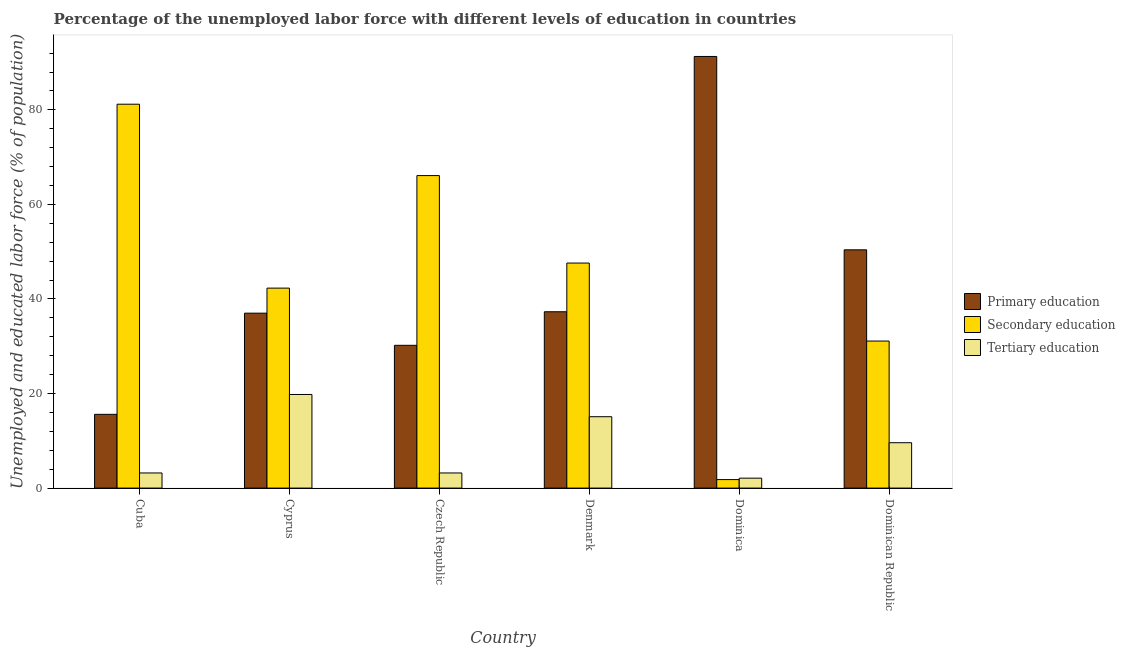Are the number of bars per tick equal to the number of legend labels?
Offer a terse response. Yes. How many bars are there on the 2nd tick from the right?
Offer a terse response. 3. What is the label of the 1st group of bars from the left?
Provide a succinct answer. Cuba. In how many cases, is the number of bars for a given country not equal to the number of legend labels?
Make the answer very short. 0. What is the percentage of labor force who received secondary education in Czech Republic?
Ensure brevity in your answer.  66.1. Across all countries, what is the maximum percentage of labor force who received primary education?
Provide a short and direct response. 91.3. Across all countries, what is the minimum percentage of labor force who received tertiary education?
Give a very brief answer. 2.1. In which country was the percentage of labor force who received secondary education maximum?
Keep it short and to the point. Cuba. In which country was the percentage of labor force who received primary education minimum?
Offer a terse response. Cuba. What is the total percentage of labor force who received secondary education in the graph?
Give a very brief answer. 270.1. What is the difference between the percentage of labor force who received primary education in Denmark and that in Dominica?
Make the answer very short. -54. What is the difference between the percentage of labor force who received tertiary education in Cyprus and the percentage of labor force who received secondary education in Czech Republic?
Give a very brief answer. -46.3. What is the average percentage of labor force who received primary education per country?
Your answer should be compact. 43.63. What is the difference between the percentage of labor force who received primary education and percentage of labor force who received tertiary education in Czech Republic?
Give a very brief answer. 27. What is the ratio of the percentage of labor force who received tertiary education in Cyprus to that in Dominican Republic?
Ensure brevity in your answer.  2.06. What is the difference between the highest and the second highest percentage of labor force who received secondary education?
Make the answer very short. 15.1. What is the difference between the highest and the lowest percentage of labor force who received primary education?
Keep it short and to the point. 75.7. In how many countries, is the percentage of labor force who received secondary education greater than the average percentage of labor force who received secondary education taken over all countries?
Ensure brevity in your answer.  3. What does the 2nd bar from the left in Cuba represents?
Keep it short and to the point. Secondary education. What is the difference between two consecutive major ticks on the Y-axis?
Give a very brief answer. 20. Does the graph contain any zero values?
Give a very brief answer. No. Does the graph contain grids?
Your answer should be very brief. No. Where does the legend appear in the graph?
Your answer should be compact. Center right. How many legend labels are there?
Provide a succinct answer. 3. What is the title of the graph?
Provide a short and direct response. Percentage of the unemployed labor force with different levels of education in countries. What is the label or title of the Y-axis?
Ensure brevity in your answer.  Unemployed and educated labor force (% of population). What is the Unemployed and educated labor force (% of population) of Primary education in Cuba?
Provide a short and direct response. 15.6. What is the Unemployed and educated labor force (% of population) in Secondary education in Cuba?
Provide a short and direct response. 81.2. What is the Unemployed and educated labor force (% of population) of Tertiary education in Cuba?
Make the answer very short. 3.2. What is the Unemployed and educated labor force (% of population) in Primary education in Cyprus?
Keep it short and to the point. 37. What is the Unemployed and educated labor force (% of population) in Secondary education in Cyprus?
Offer a very short reply. 42.3. What is the Unemployed and educated labor force (% of population) in Tertiary education in Cyprus?
Provide a short and direct response. 19.8. What is the Unemployed and educated labor force (% of population) of Primary education in Czech Republic?
Ensure brevity in your answer.  30.2. What is the Unemployed and educated labor force (% of population) of Secondary education in Czech Republic?
Your answer should be compact. 66.1. What is the Unemployed and educated labor force (% of population) in Tertiary education in Czech Republic?
Your answer should be compact. 3.2. What is the Unemployed and educated labor force (% of population) in Primary education in Denmark?
Give a very brief answer. 37.3. What is the Unemployed and educated labor force (% of population) in Secondary education in Denmark?
Provide a short and direct response. 47.6. What is the Unemployed and educated labor force (% of population) in Tertiary education in Denmark?
Offer a terse response. 15.1. What is the Unemployed and educated labor force (% of population) in Primary education in Dominica?
Offer a very short reply. 91.3. What is the Unemployed and educated labor force (% of population) of Secondary education in Dominica?
Your answer should be compact. 1.8. What is the Unemployed and educated labor force (% of population) in Tertiary education in Dominica?
Your response must be concise. 2.1. What is the Unemployed and educated labor force (% of population) of Primary education in Dominican Republic?
Give a very brief answer. 50.4. What is the Unemployed and educated labor force (% of population) in Secondary education in Dominican Republic?
Provide a short and direct response. 31.1. What is the Unemployed and educated labor force (% of population) of Tertiary education in Dominican Republic?
Offer a terse response. 9.6. Across all countries, what is the maximum Unemployed and educated labor force (% of population) of Primary education?
Ensure brevity in your answer.  91.3. Across all countries, what is the maximum Unemployed and educated labor force (% of population) of Secondary education?
Offer a terse response. 81.2. Across all countries, what is the maximum Unemployed and educated labor force (% of population) of Tertiary education?
Ensure brevity in your answer.  19.8. Across all countries, what is the minimum Unemployed and educated labor force (% of population) in Primary education?
Your response must be concise. 15.6. Across all countries, what is the minimum Unemployed and educated labor force (% of population) of Secondary education?
Your answer should be compact. 1.8. Across all countries, what is the minimum Unemployed and educated labor force (% of population) in Tertiary education?
Provide a short and direct response. 2.1. What is the total Unemployed and educated labor force (% of population) of Primary education in the graph?
Ensure brevity in your answer.  261.8. What is the total Unemployed and educated labor force (% of population) in Secondary education in the graph?
Your response must be concise. 270.1. What is the total Unemployed and educated labor force (% of population) of Tertiary education in the graph?
Ensure brevity in your answer.  53. What is the difference between the Unemployed and educated labor force (% of population) in Primary education in Cuba and that in Cyprus?
Make the answer very short. -21.4. What is the difference between the Unemployed and educated labor force (% of population) in Secondary education in Cuba and that in Cyprus?
Offer a terse response. 38.9. What is the difference between the Unemployed and educated labor force (% of population) in Tertiary education in Cuba and that in Cyprus?
Your answer should be compact. -16.6. What is the difference between the Unemployed and educated labor force (% of population) in Primary education in Cuba and that in Czech Republic?
Ensure brevity in your answer.  -14.6. What is the difference between the Unemployed and educated labor force (% of population) of Tertiary education in Cuba and that in Czech Republic?
Offer a terse response. 0. What is the difference between the Unemployed and educated labor force (% of population) in Primary education in Cuba and that in Denmark?
Give a very brief answer. -21.7. What is the difference between the Unemployed and educated labor force (% of population) of Secondary education in Cuba and that in Denmark?
Offer a terse response. 33.6. What is the difference between the Unemployed and educated labor force (% of population) in Tertiary education in Cuba and that in Denmark?
Your answer should be compact. -11.9. What is the difference between the Unemployed and educated labor force (% of population) in Primary education in Cuba and that in Dominica?
Make the answer very short. -75.7. What is the difference between the Unemployed and educated labor force (% of population) of Secondary education in Cuba and that in Dominica?
Give a very brief answer. 79.4. What is the difference between the Unemployed and educated labor force (% of population) in Primary education in Cuba and that in Dominican Republic?
Your answer should be compact. -34.8. What is the difference between the Unemployed and educated labor force (% of population) in Secondary education in Cuba and that in Dominican Republic?
Provide a succinct answer. 50.1. What is the difference between the Unemployed and educated labor force (% of population) in Tertiary education in Cuba and that in Dominican Republic?
Provide a short and direct response. -6.4. What is the difference between the Unemployed and educated labor force (% of population) in Secondary education in Cyprus and that in Czech Republic?
Your answer should be compact. -23.8. What is the difference between the Unemployed and educated labor force (% of population) in Tertiary education in Cyprus and that in Czech Republic?
Your answer should be very brief. 16.6. What is the difference between the Unemployed and educated labor force (% of population) of Primary education in Cyprus and that in Denmark?
Keep it short and to the point. -0.3. What is the difference between the Unemployed and educated labor force (% of population) of Tertiary education in Cyprus and that in Denmark?
Keep it short and to the point. 4.7. What is the difference between the Unemployed and educated labor force (% of population) of Primary education in Cyprus and that in Dominica?
Keep it short and to the point. -54.3. What is the difference between the Unemployed and educated labor force (% of population) in Secondary education in Cyprus and that in Dominica?
Keep it short and to the point. 40.5. What is the difference between the Unemployed and educated labor force (% of population) in Tertiary education in Cyprus and that in Dominica?
Your response must be concise. 17.7. What is the difference between the Unemployed and educated labor force (% of population) of Tertiary education in Cyprus and that in Dominican Republic?
Provide a short and direct response. 10.2. What is the difference between the Unemployed and educated labor force (% of population) of Primary education in Czech Republic and that in Denmark?
Provide a succinct answer. -7.1. What is the difference between the Unemployed and educated labor force (% of population) in Primary education in Czech Republic and that in Dominica?
Keep it short and to the point. -61.1. What is the difference between the Unemployed and educated labor force (% of population) in Secondary education in Czech Republic and that in Dominica?
Your answer should be compact. 64.3. What is the difference between the Unemployed and educated labor force (% of population) in Primary education in Czech Republic and that in Dominican Republic?
Your response must be concise. -20.2. What is the difference between the Unemployed and educated labor force (% of population) of Secondary education in Czech Republic and that in Dominican Republic?
Ensure brevity in your answer.  35. What is the difference between the Unemployed and educated labor force (% of population) of Tertiary education in Czech Republic and that in Dominican Republic?
Your answer should be compact. -6.4. What is the difference between the Unemployed and educated labor force (% of population) in Primary education in Denmark and that in Dominica?
Your response must be concise. -54. What is the difference between the Unemployed and educated labor force (% of population) of Secondary education in Denmark and that in Dominica?
Offer a very short reply. 45.8. What is the difference between the Unemployed and educated labor force (% of population) in Tertiary education in Denmark and that in Dominica?
Make the answer very short. 13. What is the difference between the Unemployed and educated labor force (% of population) of Secondary education in Denmark and that in Dominican Republic?
Provide a succinct answer. 16.5. What is the difference between the Unemployed and educated labor force (% of population) of Primary education in Dominica and that in Dominican Republic?
Keep it short and to the point. 40.9. What is the difference between the Unemployed and educated labor force (% of population) in Secondary education in Dominica and that in Dominican Republic?
Keep it short and to the point. -29.3. What is the difference between the Unemployed and educated labor force (% of population) in Primary education in Cuba and the Unemployed and educated labor force (% of population) in Secondary education in Cyprus?
Make the answer very short. -26.7. What is the difference between the Unemployed and educated labor force (% of population) in Secondary education in Cuba and the Unemployed and educated labor force (% of population) in Tertiary education in Cyprus?
Provide a succinct answer. 61.4. What is the difference between the Unemployed and educated labor force (% of population) of Primary education in Cuba and the Unemployed and educated labor force (% of population) of Secondary education in Czech Republic?
Keep it short and to the point. -50.5. What is the difference between the Unemployed and educated labor force (% of population) in Primary education in Cuba and the Unemployed and educated labor force (% of population) in Tertiary education in Czech Republic?
Offer a terse response. 12.4. What is the difference between the Unemployed and educated labor force (% of population) in Secondary education in Cuba and the Unemployed and educated labor force (% of population) in Tertiary education in Czech Republic?
Make the answer very short. 78. What is the difference between the Unemployed and educated labor force (% of population) in Primary education in Cuba and the Unemployed and educated labor force (% of population) in Secondary education in Denmark?
Your answer should be compact. -32. What is the difference between the Unemployed and educated labor force (% of population) of Secondary education in Cuba and the Unemployed and educated labor force (% of population) of Tertiary education in Denmark?
Ensure brevity in your answer.  66.1. What is the difference between the Unemployed and educated labor force (% of population) in Primary education in Cuba and the Unemployed and educated labor force (% of population) in Tertiary education in Dominica?
Ensure brevity in your answer.  13.5. What is the difference between the Unemployed and educated labor force (% of population) in Secondary education in Cuba and the Unemployed and educated labor force (% of population) in Tertiary education in Dominica?
Offer a terse response. 79.1. What is the difference between the Unemployed and educated labor force (% of population) in Primary education in Cuba and the Unemployed and educated labor force (% of population) in Secondary education in Dominican Republic?
Make the answer very short. -15.5. What is the difference between the Unemployed and educated labor force (% of population) in Primary education in Cuba and the Unemployed and educated labor force (% of population) in Tertiary education in Dominican Republic?
Give a very brief answer. 6. What is the difference between the Unemployed and educated labor force (% of population) in Secondary education in Cuba and the Unemployed and educated labor force (% of population) in Tertiary education in Dominican Republic?
Keep it short and to the point. 71.6. What is the difference between the Unemployed and educated labor force (% of population) in Primary education in Cyprus and the Unemployed and educated labor force (% of population) in Secondary education in Czech Republic?
Keep it short and to the point. -29.1. What is the difference between the Unemployed and educated labor force (% of population) of Primary education in Cyprus and the Unemployed and educated labor force (% of population) of Tertiary education in Czech Republic?
Offer a terse response. 33.8. What is the difference between the Unemployed and educated labor force (% of population) of Secondary education in Cyprus and the Unemployed and educated labor force (% of population) of Tertiary education in Czech Republic?
Your response must be concise. 39.1. What is the difference between the Unemployed and educated labor force (% of population) of Primary education in Cyprus and the Unemployed and educated labor force (% of population) of Tertiary education in Denmark?
Offer a very short reply. 21.9. What is the difference between the Unemployed and educated labor force (% of population) of Secondary education in Cyprus and the Unemployed and educated labor force (% of population) of Tertiary education in Denmark?
Give a very brief answer. 27.2. What is the difference between the Unemployed and educated labor force (% of population) of Primary education in Cyprus and the Unemployed and educated labor force (% of population) of Secondary education in Dominica?
Offer a terse response. 35.2. What is the difference between the Unemployed and educated labor force (% of population) in Primary education in Cyprus and the Unemployed and educated labor force (% of population) in Tertiary education in Dominica?
Give a very brief answer. 34.9. What is the difference between the Unemployed and educated labor force (% of population) of Secondary education in Cyprus and the Unemployed and educated labor force (% of population) of Tertiary education in Dominica?
Offer a very short reply. 40.2. What is the difference between the Unemployed and educated labor force (% of population) of Primary education in Cyprus and the Unemployed and educated labor force (% of population) of Tertiary education in Dominican Republic?
Your answer should be very brief. 27.4. What is the difference between the Unemployed and educated labor force (% of population) of Secondary education in Cyprus and the Unemployed and educated labor force (% of population) of Tertiary education in Dominican Republic?
Your answer should be very brief. 32.7. What is the difference between the Unemployed and educated labor force (% of population) of Primary education in Czech Republic and the Unemployed and educated labor force (% of population) of Secondary education in Denmark?
Provide a short and direct response. -17.4. What is the difference between the Unemployed and educated labor force (% of population) of Primary education in Czech Republic and the Unemployed and educated labor force (% of population) of Secondary education in Dominica?
Provide a short and direct response. 28.4. What is the difference between the Unemployed and educated labor force (% of population) of Primary education in Czech Republic and the Unemployed and educated labor force (% of population) of Tertiary education in Dominica?
Your answer should be compact. 28.1. What is the difference between the Unemployed and educated labor force (% of population) in Secondary education in Czech Republic and the Unemployed and educated labor force (% of population) in Tertiary education in Dominica?
Offer a terse response. 64. What is the difference between the Unemployed and educated labor force (% of population) of Primary education in Czech Republic and the Unemployed and educated labor force (% of population) of Tertiary education in Dominican Republic?
Your answer should be compact. 20.6. What is the difference between the Unemployed and educated labor force (% of population) of Secondary education in Czech Republic and the Unemployed and educated labor force (% of population) of Tertiary education in Dominican Republic?
Offer a terse response. 56.5. What is the difference between the Unemployed and educated labor force (% of population) in Primary education in Denmark and the Unemployed and educated labor force (% of population) in Secondary education in Dominica?
Give a very brief answer. 35.5. What is the difference between the Unemployed and educated labor force (% of population) of Primary education in Denmark and the Unemployed and educated labor force (% of population) of Tertiary education in Dominica?
Provide a short and direct response. 35.2. What is the difference between the Unemployed and educated labor force (% of population) in Secondary education in Denmark and the Unemployed and educated labor force (% of population) in Tertiary education in Dominica?
Provide a short and direct response. 45.5. What is the difference between the Unemployed and educated labor force (% of population) of Primary education in Denmark and the Unemployed and educated labor force (% of population) of Secondary education in Dominican Republic?
Make the answer very short. 6.2. What is the difference between the Unemployed and educated labor force (% of population) in Primary education in Denmark and the Unemployed and educated labor force (% of population) in Tertiary education in Dominican Republic?
Your answer should be compact. 27.7. What is the difference between the Unemployed and educated labor force (% of population) of Secondary education in Denmark and the Unemployed and educated labor force (% of population) of Tertiary education in Dominican Republic?
Keep it short and to the point. 38. What is the difference between the Unemployed and educated labor force (% of population) of Primary education in Dominica and the Unemployed and educated labor force (% of population) of Secondary education in Dominican Republic?
Provide a short and direct response. 60.2. What is the difference between the Unemployed and educated labor force (% of population) in Primary education in Dominica and the Unemployed and educated labor force (% of population) in Tertiary education in Dominican Republic?
Your answer should be compact. 81.7. What is the difference between the Unemployed and educated labor force (% of population) of Secondary education in Dominica and the Unemployed and educated labor force (% of population) of Tertiary education in Dominican Republic?
Provide a short and direct response. -7.8. What is the average Unemployed and educated labor force (% of population) in Primary education per country?
Give a very brief answer. 43.63. What is the average Unemployed and educated labor force (% of population) of Secondary education per country?
Your answer should be compact. 45.02. What is the average Unemployed and educated labor force (% of population) of Tertiary education per country?
Give a very brief answer. 8.83. What is the difference between the Unemployed and educated labor force (% of population) of Primary education and Unemployed and educated labor force (% of population) of Secondary education in Cuba?
Give a very brief answer. -65.6. What is the difference between the Unemployed and educated labor force (% of population) in Primary education and Unemployed and educated labor force (% of population) in Tertiary education in Cuba?
Offer a terse response. 12.4. What is the difference between the Unemployed and educated labor force (% of population) of Primary education and Unemployed and educated labor force (% of population) of Secondary education in Cyprus?
Your answer should be very brief. -5.3. What is the difference between the Unemployed and educated labor force (% of population) of Primary education and Unemployed and educated labor force (% of population) of Tertiary education in Cyprus?
Ensure brevity in your answer.  17.2. What is the difference between the Unemployed and educated labor force (% of population) in Secondary education and Unemployed and educated labor force (% of population) in Tertiary education in Cyprus?
Your answer should be very brief. 22.5. What is the difference between the Unemployed and educated labor force (% of population) in Primary education and Unemployed and educated labor force (% of population) in Secondary education in Czech Republic?
Provide a short and direct response. -35.9. What is the difference between the Unemployed and educated labor force (% of population) of Secondary education and Unemployed and educated labor force (% of population) of Tertiary education in Czech Republic?
Provide a short and direct response. 62.9. What is the difference between the Unemployed and educated labor force (% of population) of Primary education and Unemployed and educated labor force (% of population) of Secondary education in Denmark?
Provide a short and direct response. -10.3. What is the difference between the Unemployed and educated labor force (% of population) in Primary education and Unemployed and educated labor force (% of population) in Tertiary education in Denmark?
Offer a terse response. 22.2. What is the difference between the Unemployed and educated labor force (% of population) in Secondary education and Unemployed and educated labor force (% of population) in Tertiary education in Denmark?
Your response must be concise. 32.5. What is the difference between the Unemployed and educated labor force (% of population) of Primary education and Unemployed and educated labor force (% of population) of Secondary education in Dominica?
Provide a succinct answer. 89.5. What is the difference between the Unemployed and educated labor force (% of population) of Primary education and Unemployed and educated labor force (% of population) of Tertiary education in Dominica?
Offer a very short reply. 89.2. What is the difference between the Unemployed and educated labor force (% of population) in Secondary education and Unemployed and educated labor force (% of population) in Tertiary education in Dominica?
Your response must be concise. -0.3. What is the difference between the Unemployed and educated labor force (% of population) of Primary education and Unemployed and educated labor force (% of population) of Secondary education in Dominican Republic?
Keep it short and to the point. 19.3. What is the difference between the Unemployed and educated labor force (% of population) in Primary education and Unemployed and educated labor force (% of population) in Tertiary education in Dominican Republic?
Provide a short and direct response. 40.8. What is the difference between the Unemployed and educated labor force (% of population) of Secondary education and Unemployed and educated labor force (% of population) of Tertiary education in Dominican Republic?
Give a very brief answer. 21.5. What is the ratio of the Unemployed and educated labor force (% of population) in Primary education in Cuba to that in Cyprus?
Provide a short and direct response. 0.42. What is the ratio of the Unemployed and educated labor force (% of population) of Secondary education in Cuba to that in Cyprus?
Give a very brief answer. 1.92. What is the ratio of the Unemployed and educated labor force (% of population) of Tertiary education in Cuba to that in Cyprus?
Give a very brief answer. 0.16. What is the ratio of the Unemployed and educated labor force (% of population) in Primary education in Cuba to that in Czech Republic?
Your answer should be compact. 0.52. What is the ratio of the Unemployed and educated labor force (% of population) in Secondary education in Cuba to that in Czech Republic?
Your answer should be compact. 1.23. What is the ratio of the Unemployed and educated labor force (% of population) of Primary education in Cuba to that in Denmark?
Give a very brief answer. 0.42. What is the ratio of the Unemployed and educated labor force (% of population) in Secondary education in Cuba to that in Denmark?
Make the answer very short. 1.71. What is the ratio of the Unemployed and educated labor force (% of population) of Tertiary education in Cuba to that in Denmark?
Keep it short and to the point. 0.21. What is the ratio of the Unemployed and educated labor force (% of population) in Primary education in Cuba to that in Dominica?
Provide a succinct answer. 0.17. What is the ratio of the Unemployed and educated labor force (% of population) of Secondary education in Cuba to that in Dominica?
Your response must be concise. 45.11. What is the ratio of the Unemployed and educated labor force (% of population) in Tertiary education in Cuba to that in Dominica?
Provide a succinct answer. 1.52. What is the ratio of the Unemployed and educated labor force (% of population) in Primary education in Cuba to that in Dominican Republic?
Give a very brief answer. 0.31. What is the ratio of the Unemployed and educated labor force (% of population) in Secondary education in Cuba to that in Dominican Republic?
Provide a succinct answer. 2.61. What is the ratio of the Unemployed and educated labor force (% of population) in Primary education in Cyprus to that in Czech Republic?
Provide a succinct answer. 1.23. What is the ratio of the Unemployed and educated labor force (% of population) of Secondary education in Cyprus to that in Czech Republic?
Your answer should be compact. 0.64. What is the ratio of the Unemployed and educated labor force (% of population) in Tertiary education in Cyprus to that in Czech Republic?
Keep it short and to the point. 6.19. What is the ratio of the Unemployed and educated labor force (% of population) in Secondary education in Cyprus to that in Denmark?
Ensure brevity in your answer.  0.89. What is the ratio of the Unemployed and educated labor force (% of population) in Tertiary education in Cyprus to that in Denmark?
Offer a terse response. 1.31. What is the ratio of the Unemployed and educated labor force (% of population) in Primary education in Cyprus to that in Dominica?
Your answer should be compact. 0.41. What is the ratio of the Unemployed and educated labor force (% of population) of Tertiary education in Cyprus to that in Dominica?
Provide a succinct answer. 9.43. What is the ratio of the Unemployed and educated labor force (% of population) in Primary education in Cyprus to that in Dominican Republic?
Offer a terse response. 0.73. What is the ratio of the Unemployed and educated labor force (% of population) of Secondary education in Cyprus to that in Dominican Republic?
Provide a short and direct response. 1.36. What is the ratio of the Unemployed and educated labor force (% of population) in Tertiary education in Cyprus to that in Dominican Republic?
Keep it short and to the point. 2.06. What is the ratio of the Unemployed and educated labor force (% of population) of Primary education in Czech Republic to that in Denmark?
Offer a terse response. 0.81. What is the ratio of the Unemployed and educated labor force (% of population) in Secondary education in Czech Republic to that in Denmark?
Your answer should be very brief. 1.39. What is the ratio of the Unemployed and educated labor force (% of population) in Tertiary education in Czech Republic to that in Denmark?
Offer a terse response. 0.21. What is the ratio of the Unemployed and educated labor force (% of population) in Primary education in Czech Republic to that in Dominica?
Keep it short and to the point. 0.33. What is the ratio of the Unemployed and educated labor force (% of population) in Secondary education in Czech Republic to that in Dominica?
Provide a succinct answer. 36.72. What is the ratio of the Unemployed and educated labor force (% of population) in Tertiary education in Czech Republic to that in Dominica?
Your answer should be very brief. 1.52. What is the ratio of the Unemployed and educated labor force (% of population) in Primary education in Czech Republic to that in Dominican Republic?
Make the answer very short. 0.6. What is the ratio of the Unemployed and educated labor force (% of population) in Secondary education in Czech Republic to that in Dominican Republic?
Ensure brevity in your answer.  2.13. What is the ratio of the Unemployed and educated labor force (% of population) in Tertiary education in Czech Republic to that in Dominican Republic?
Offer a very short reply. 0.33. What is the ratio of the Unemployed and educated labor force (% of population) of Primary education in Denmark to that in Dominica?
Ensure brevity in your answer.  0.41. What is the ratio of the Unemployed and educated labor force (% of population) in Secondary education in Denmark to that in Dominica?
Your response must be concise. 26.44. What is the ratio of the Unemployed and educated labor force (% of population) in Tertiary education in Denmark to that in Dominica?
Your answer should be very brief. 7.19. What is the ratio of the Unemployed and educated labor force (% of population) in Primary education in Denmark to that in Dominican Republic?
Your answer should be very brief. 0.74. What is the ratio of the Unemployed and educated labor force (% of population) in Secondary education in Denmark to that in Dominican Republic?
Your answer should be very brief. 1.53. What is the ratio of the Unemployed and educated labor force (% of population) in Tertiary education in Denmark to that in Dominican Republic?
Give a very brief answer. 1.57. What is the ratio of the Unemployed and educated labor force (% of population) of Primary education in Dominica to that in Dominican Republic?
Your answer should be compact. 1.81. What is the ratio of the Unemployed and educated labor force (% of population) of Secondary education in Dominica to that in Dominican Republic?
Offer a terse response. 0.06. What is the ratio of the Unemployed and educated labor force (% of population) of Tertiary education in Dominica to that in Dominican Republic?
Provide a short and direct response. 0.22. What is the difference between the highest and the second highest Unemployed and educated labor force (% of population) of Primary education?
Keep it short and to the point. 40.9. What is the difference between the highest and the lowest Unemployed and educated labor force (% of population) in Primary education?
Provide a succinct answer. 75.7. What is the difference between the highest and the lowest Unemployed and educated labor force (% of population) in Secondary education?
Provide a succinct answer. 79.4. What is the difference between the highest and the lowest Unemployed and educated labor force (% of population) in Tertiary education?
Make the answer very short. 17.7. 